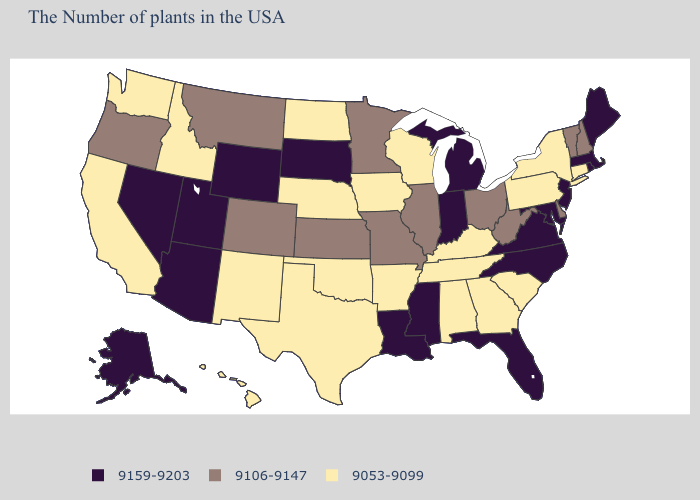What is the highest value in states that border Washington?
Keep it brief. 9106-9147. Name the states that have a value in the range 9106-9147?
Give a very brief answer. New Hampshire, Vermont, Delaware, West Virginia, Ohio, Illinois, Missouri, Minnesota, Kansas, Colorado, Montana, Oregon. What is the lowest value in states that border New Hampshire?
Short answer required. 9106-9147. What is the value of Kentucky?
Answer briefly. 9053-9099. What is the value of South Dakota?
Short answer required. 9159-9203. Does the first symbol in the legend represent the smallest category?
Concise answer only. No. Name the states that have a value in the range 9106-9147?
Keep it brief. New Hampshire, Vermont, Delaware, West Virginia, Ohio, Illinois, Missouri, Minnesota, Kansas, Colorado, Montana, Oregon. What is the value of Montana?
Answer briefly. 9106-9147. Name the states that have a value in the range 9053-9099?
Concise answer only. Connecticut, New York, Pennsylvania, South Carolina, Georgia, Kentucky, Alabama, Tennessee, Wisconsin, Arkansas, Iowa, Nebraska, Oklahoma, Texas, North Dakota, New Mexico, Idaho, California, Washington, Hawaii. What is the value of Wyoming?
Concise answer only. 9159-9203. Does Mississippi have the same value as Utah?
Keep it brief. Yes. What is the lowest value in states that border Louisiana?
Short answer required. 9053-9099. What is the highest value in the West ?
Give a very brief answer. 9159-9203. Is the legend a continuous bar?
Be succinct. No. Does Iowa have the highest value in the MidWest?
Short answer required. No. 